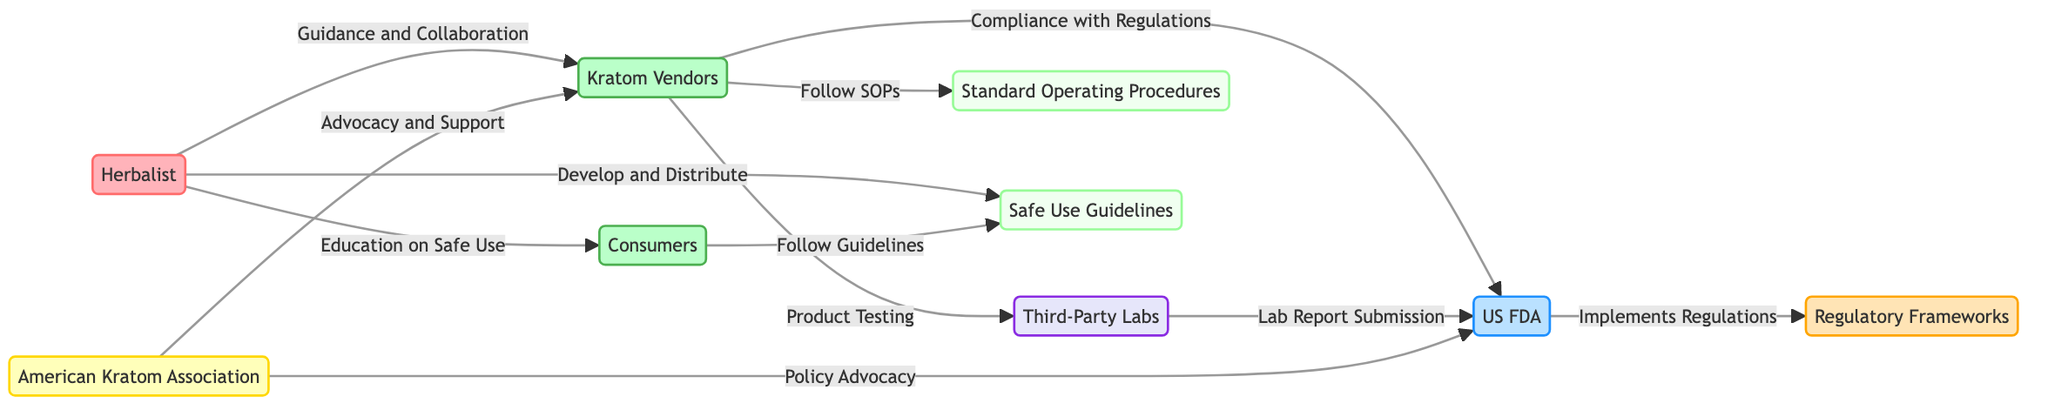What is the total number of nodes in the diagram? By counting each unique node represented in the diagram, we identify them as Herbalist, Kratom Vendors, US FDA, American Kratom Association, Third-Party Labs, Consumers, Regulatory Frameworks, Standard Operating Procedures, and Safe Use Guidelines, totaling nine distinct nodes.
Answer: 9 What is the relationship between Kratom Vendors and the US FDA? The edge connecting Kratom Vendors to the US FDA is labeled "Compliance with Regulations", indicating that Kratom Vendors need to adhere to the regulations set forth by the US FDA.
Answer: Compliance with Regulations How many edges connect the American Kratom Association to other nodes? Examining the edges leading from the American Kratom Association shows it is connected to two nodes: Kratom Vendors and the US FDA, thus there are two edges in total.
Answer: 2 What is the role of Third-Party Labs in the network? Third-Party Labs are involved in "Product Testing", indicating their function is related to assessing the quality or safety of Kratom products and submitting lab reports to the US FDA.
Answer: Product Testing Which node is responsible for developing and distributing safe use guidelines? The Herbalist node is directly connected to the Safe Use Guidelines and labeled "Develop and Distribute", meaning that the Herbalist takes the initiative in creating and sharing these guidelines.
Answer: Herbalist What kind of support do Kratom Vendors receive from the American Kratom Association? The edge from the American Kratom Association to Kratom Vendors is labeled "Advocacy and Support", signifying that the Association provides encouragement and assistance to the vendors in the industry.
Answer: Advocacy and Support Which two entities are involved in the submission of lab reports? The Third-Party Labs are connected to both the Kratom Vendors (for testing) and to the US FDA (for report submission). The direct edge from Third-Party Labs to the US FDA labeled "Lab Report Submission" indicates this connection.
Answer: Third-Party Labs and US FDA What type of guidelines do consumers need to follow as indicated in the diagram? The Consumers node has an outgoing edge labeled "Follow Guidelines" connecting to the Safe Use Guidelines, suggesting that consumers are expected to adhere to these guidelines for safe Kratom use.
Answer: Safe Use Guidelines Which node implements regulatory frameworks? The US FDA is responsible for implementing the Regulatory Frameworks, as indicated by the directed edge labeled "Implements Regulations" leading from the US FDA to the Regulatory Frameworks node.
Answer: US FDA 